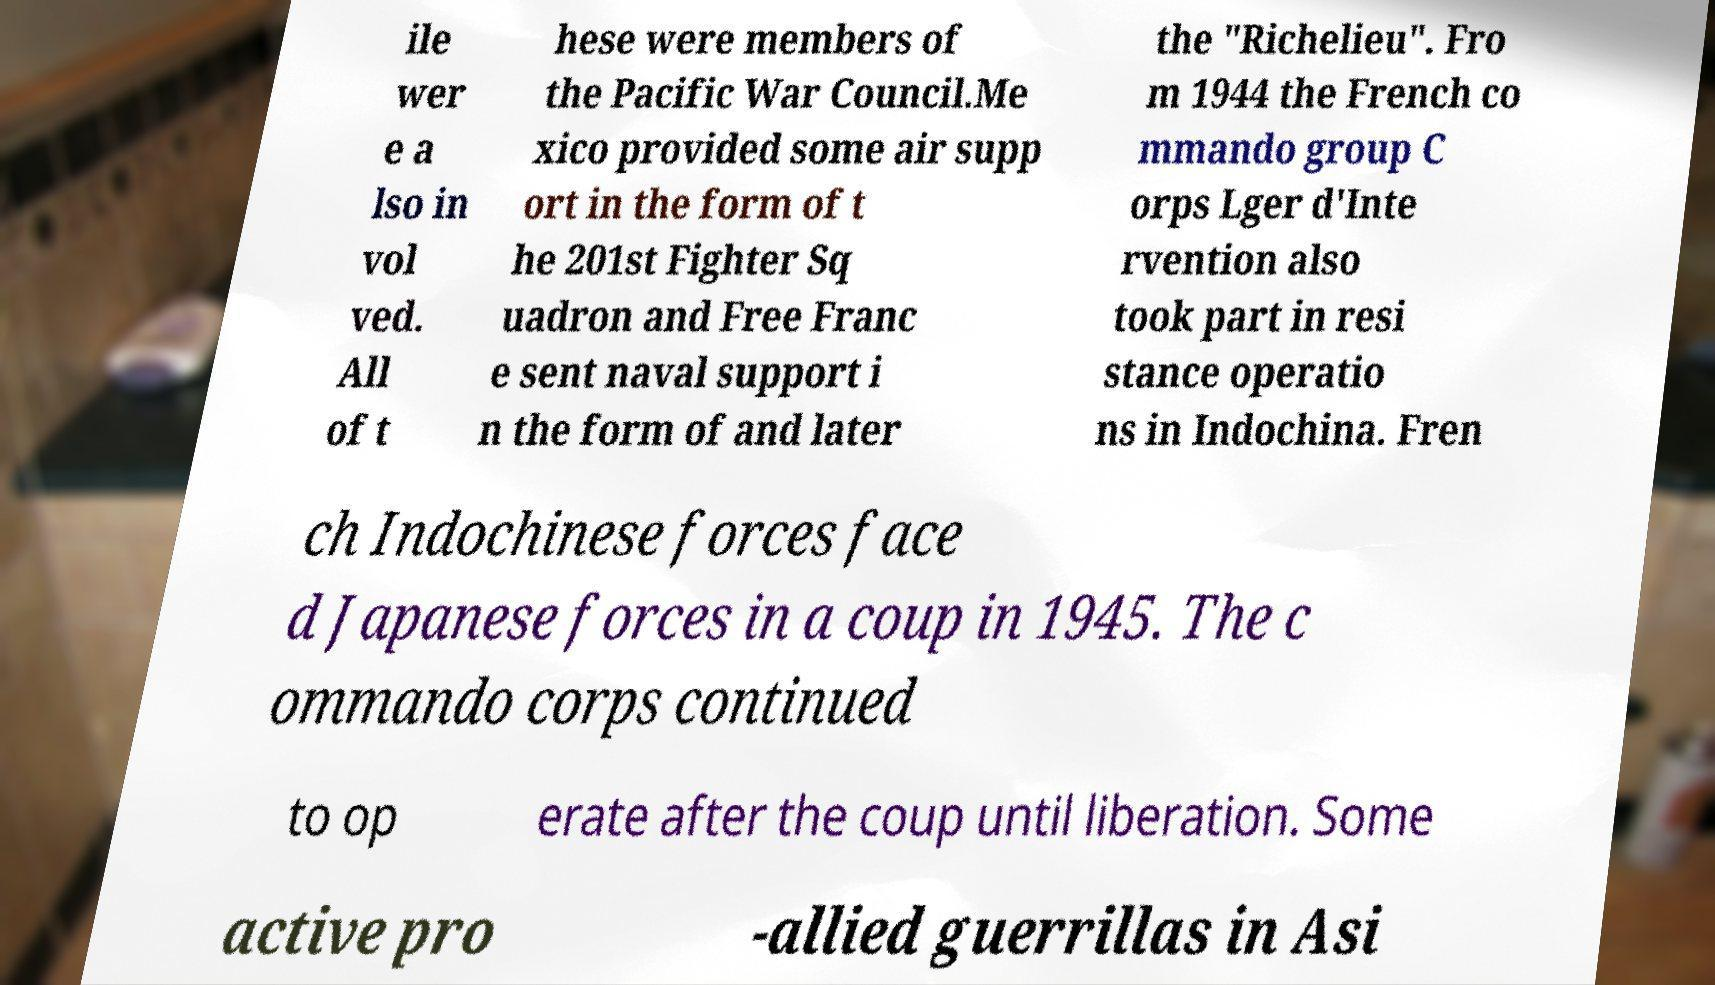What messages or text are displayed in this image? I need them in a readable, typed format. ile wer e a lso in vol ved. All of t hese were members of the Pacific War Council.Me xico provided some air supp ort in the form of t he 201st Fighter Sq uadron and Free Franc e sent naval support i n the form of and later the "Richelieu". Fro m 1944 the French co mmando group C orps Lger d'Inte rvention also took part in resi stance operatio ns in Indochina. Fren ch Indochinese forces face d Japanese forces in a coup in 1945. The c ommando corps continued to op erate after the coup until liberation. Some active pro -allied guerrillas in Asi 